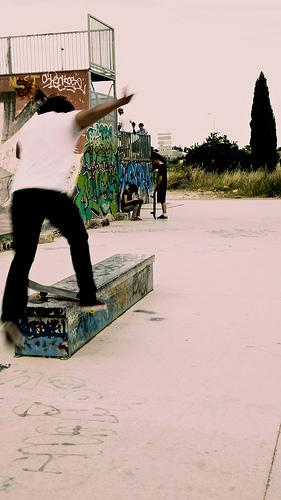What can you say about the footwear of the woman in the image? Her right shoe is visible, as well as her left foot on a skateboard. Identify the main activity happening in the image. People are skateboarding and hanging out in a park with graffiti. What is the most visible color on the walls and ground? Graffiti in various colors, such as blue and green, is visible on the walls and ground. Describe the type of trees in the image. Tall dark green pine trees and tall green trees are visible in the distance. Mention two objects in the image related to skateboarding. A boy doing a trick on a skateboard, and a black skateboard with yellow wheels. In the image, how does the sky look like? The sky is grey and cloudy in the background. Enumerate three noticeable features in the image. Graffiti on the ground, a tall dark green pine tree, and people skateboarding. What is the dominant weather condition displayed in the image? It is a cloudy day with light pale clear skies. Describe the area where the people are gathered in the image. The people are gathered in a skateboard park with graffiti and tall grass nearby. What type of people can be seen in this image, and what are they wearing? Young individuals mostly wearing dark outfits, some with skateboards and one emo kid having a conversation. Is the white street light pole located in front of the tall dark green pine tree? The instruction combines two separate elements, "white street light pole" and "tall dark green pine tree," and wrongfully implies a relation between their positions in the image when no such relation exists. Are there red spots of liquid on the ground? There are "spots of liquid on the ground" mentioned, but the color of the liquid is not specified; adding the color red is misleading. Describe the sky in the image. It has light pale clear skies and grey cloudy areas. List two objects/people found in the skateboard park. A boy doing a trick on a skateboard, and a man with black outfit standing Identify the activity of the boy with the skateboard. He is doing a trick on the skateboard. Describe the location of the graffiti-covered stone bench relative to the black man skateboarding on a bench. The graffiti-covered stone bench is slightly behind and to the right. What is a unique feature of the skateboard mentioned in the image? It has yellow wheels. Create a short poem about the scene in the image. In the park they gathered, young souls free, Which of these objects can be found in the image? (A) A basketball hoop, (B) A white street light pole, (C) A hot dog stand B (A white street light pole) What are some objects in the image that have graffiti on them? Ground, wall, the cement block, and the stone bench What's the expression of the people talking to each other? We cannot determine their facial expressions. Is the metal hand railing made of wood? The instruction refers to a "metal hand railing," but falsely claims it's made of wood, which contradicts the given information about the material. Identify two types of plants in the image. Tall grass and pine trees Is the person wearing the white shirt in motion? Yes How would you describe the color of the ground? Tan Can you see a group of people wearing yellow hats near the trees? The instruction adds a group of people wearing yellow hats, which can't be found in the given information. This introduces elements that don't exist in the image. Complete the sentence: The black man on the ____ is skateboarding. bench What type of trees can be seen in the distance? Tall dark green pine trees Provide a caption for the image. People enjoying themselves at a graffiti-filled skateboard park with cloudy skies overhead. Is the graffiti on the side of a structure pink and purple? The instructions mention "graffiti on the side of a structure," but no specific colors are given for the graffiti. Assigning pink and purple is inaccurate. Is there a metal fenced balcony in the image? Yes, on top of a building. Is the boy doing a trick on a skateboard wearing a white shirt? The instruction refers to the boy doing a trick on a skateboard, but wrongfully assigns a white shirt when no specific color is mentioned for the boy's shirt. Identify the type of barrier on the rooftop. Steel barrier Determine if the following statement is true: The cement ground is covered in graffiti. True Which of the following sentences accurately describes the scene in the image? (A) The people are playing basketball, (B) The people are hanging out in a skate park, or (C) The people are attending a concert. B (The people are hanging out in a skate park) 